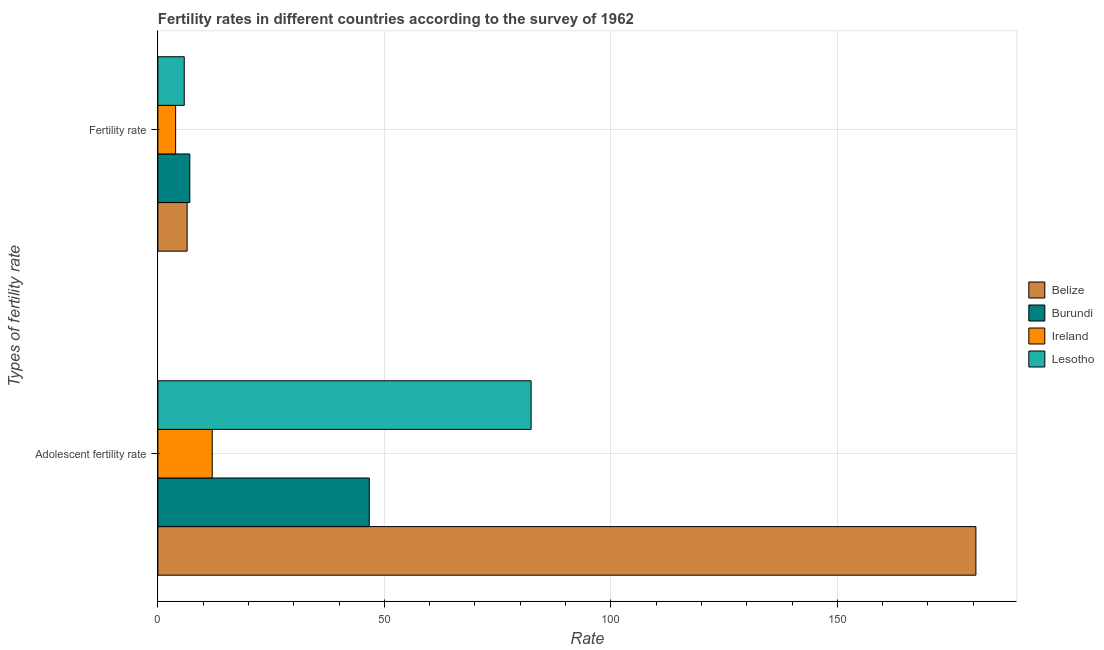How many different coloured bars are there?
Make the answer very short. 4. How many bars are there on the 1st tick from the top?
Keep it short and to the point. 4. How many bars are there on the 2nd tick from the bottom?
Provide a short and direct response. 4. What is the label of the 2nd group of bars from the top?
Your answer should be compact. Adolescent fertility rate. What is the fertility rate in Ireland?
Provide a succinct answer. 3.92. Across all countries, what is the maximum fertility rate?
Keep it short and to the point. 7.04. In which country was the adolescent fertility rate maximum?
Your response must be concise. Belize. In which country was the fertility rate minimum?
Your answer should be compact. Ireland. What is the total fertility rate in the graph?
Your answer should be compact. 23.24. What is the difference between the adolescent fertility rate in Lesotho and that in Ireland?
Your response must be concise. 70.4. What is the difference between the adolescent fertility rate in Belize and the fertility rate in Burundi?
Make the answer very short. 173.56. What is the average adolescent fertility rate per country?
Make the answer very short. 80.42. What is the difference between the adolescent fertility rate and fertility rate in Belize?
Your answer should be compact. 174.14. What is the ratio of the adolescent fertility rate in Lesotho to that in Belize?
Give a very brief answer. 0.46. Is the adolescent fertility rate in Lesotho less than that in Burundi?
Give a very brief answer. No. What does the 3rd bar from the top in Adolescent fertility rate represents?
Provide a succinct answer. Burundi. What does the 3rd bar from the bottom in Fertility rate represents?
Your answer should be very brief. Ireland. Are all the bars in the graph horizontal?
Make the answer very short. Yes. How many countries are there in the graph?
Provide a short and direct response. 4. Does the graph contain grids?
Offer a very short reply. Yes. How many legend labels are there?
Your response must be concise. 4. How are the legend labels stacked?
Offer a very short reply. Vertical. What is the title of the graph?
Your answer should be compact. Fertility rates in different countries according to the survey of 1962. What is the label or title of the X-axis?
Offer a terse response. Rate. What is the label or title of the Y-axis?
Give a very brief answer. Types of fertility rate. What is the Rate of Belize in Adolescent fertility rate?
Give a very brief answer. 180.6. What is the Rate of Burundi in Adolescent fertility rate?
Provide a short and direct response. 46.67. What is the Rate of Lesotho in Adolescent fertility rate?
Make the answer very short. 82.4. What is the Rate in Belize in Fertility rate?
Keep it short and to the point. 6.46. What is the Rate in Burundi in Fertility rate?
Your answer should be compact. 7.04. What is the Rate of Ireland in Fertility rate?
Make the answer very short. 3.92. What is the Rate in Lesotho in Fertility rate?
Your response must be concise. 5.82. Across all Types of fertility rate, what is the maximum Rate of Belize?
Give a very brief answer. 180.6. Across all Types of fertility rate, what is the maximum Rate of Burundi?
Your answer should be compact. 46.67. Across all Types of fertility rate, what is the maximum Rate in Lesotho?
Keep it short and to the point. 82.4. Across all Types of fertility rate, what is the minimum Rate in Belize?
Make the answer very short. 6.46. Across all Types of fertility rate, what is the minimum Rate in Burundi?
Give a very brief answer. 7.04. Across all Types of fertility rate, what is the minimum Rate in Ireland?
Provide a short and direct response. 3.92. Across all Types of fertility rate, what is the minimum Rate of Lesotho?
Offer a very short reply. 5.82. What is the total Rate of Belize in the graph?
Provide a short and direct response. 187.06. What is the total Rate of Burundi in the graph?
Offer a terse response. 53.71. What is the total Rate of Ireland in the graph?
Your response must be concise. 15.92. What is the total Rate in Lesotho in the graph?
Offer a very short reply. 88.22. What is the difference between the Rate of Belize in Adolescent fertility rate and that in Fertility rate?
Offer a very short reply. 174.14. What is the difference between the Rate of Burundi in Adolescent fertility rate and that in Fertility rate?
Provide a short and direct response. 39.62. What is the difference between the Rate of Ireland in Adolescent fertility rate and that in Fertility rate?
Provide a short and direct response. 8.08. What is the difference between the Rate of Lesotho in Adolescent fertility rate and that in Fertility rate?
Your answer should be very brief. 76.58. What is the difference between the Rate in Belize in Adolescent fertility rate and the Rate in Burundi in Fertility rate?
Offer a terse response. 173.56. What is the difference between the Rate of Belize in Adolescent fertility rate and the Rate of Ireland in Fertility rate?
Offer a very short reply. 176.68. What is the difference between the Rate of Belize in Adolescent fertility rate and the Rate of Lesotho in Fertility rate?
Your response must be concise. 174.78. What is the difference between the Rate of Burundi in Adolescent fertility rate and the Rate of Ireland in Fertility rate?
Your answer should be very brief. 42.75. What is the difference between the Rate of Burundi in Adolescent fertility rate and the Rate of Lesotho in Fertility rate?
Keep it short and to the point. 40.85. What is the difference between the Rate in Ireland in Adolescent fertility rate and the Rate in Lesotho in Fertility rate?
Your answer should be compact. 6.18. What is the average Rate in Belize per Types of fertility rate?
Offer a terse response. 93.53. What is the average Rate in Burundi per Types of fertility rate?
Provide a short and direct response. 26.86. What is the average Rate in Ireland per Types of fertility rate?
Give a very brief answer. 7.96. What is the average Rate in Lesotho per Types of fertility rate?
Your response must be concise. 44.11. What is the difference between the Rate in Belize and Rate in Burundi in Adolescent fertility rate?
Give a very brief answer. 133.93. What is the difference between the Rate of Belize and Rate of Ireland in Adolescent fertility rate?
Keep it short and to the point. 168.6. What is the difference between the Rate in Belize and Rate in Lesotho in Adolescent fertility rate?
Offer a very short reply. 98.2. What is the difference between the Rate of Burundi and Rate of Ireland in Adolescent fertility rate?
Your answer should be compact. 34.67. What is the difference between the Rate of Burundi and Rate of Lesotho in Adolescent fertility rate?
Provide a succinct answer. -35.73. What is the difference between the Rate in Ireland and Rate in Lesotho in Adolescent fertility rate?
Make the answer very short. -70.4. What is the difference between the Rate in Belize and Rate in Burundi in Fertility rate?
Your response must be concise. -0.58. What is the difference between the Rate of Belize and Rate of Ireland in Fertility rate?
Give a very brief answer. 2.54. What is the difference between the Rate of Belize and Rate of Lesotho in Fertility rate?
Your answer should be very brief. 0.64. What is the difference between the Rate of Burundi and Rate of Ireland in Fertility rate?
Provide a short and direct response. 3.12. What is the difference between the Rate in Burundi and Rate in Lesotho in Fertility rate?
Ensure brevity in your answer.  1.23. What is the ratio of the Rate in Belize in Adolescent fertility rate to that in Fertility rate?
Make the answer very short. 27.96. What is the ratio of the Rate of Burundi in Adolescent fertility rate to that in Fertility rate?
Offer a terse response. 6.62. What is the ratio of the Rate in Ireland in Adolescent fertility rate to that in Fertility rate?
Offer a very short reply. 3.06. What is the ratio of the Rate in Lesotho in Adolescent fertility rate to that in Fertility rate?
Ensure brevity in your answer.  14.16. What is the difference between the highest and the second highest Rate in Belize?
Provide a short and direct response. 174.14. What is the difference between the highest and the second highest Rate of Burundi?
Your answer should be very brief. 39.62. What is the difference between the highest and the second highest Rate of Ireland?
Ensure brevity in your answer.  8.08. What is the difference between the highest and the second highest Rate of Lesotho?
Offer a very short reply. 76.58. What is the difference between the highest and the lowest Rate in Belize?
Your answer should be compact. 174.14. What is the difference between the highest and the lowest Rate of Burundi?
Your answer should be compact. 39.62. What is the difference between the highest and the lowest Rate in Ireland?
Ensure brevity in your answer.  8.08. What is the difference between the highest and the lowest Rate of Lesotho?
Make the answer very short. 76.58. 